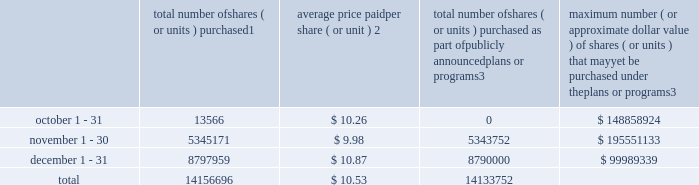Repurchase of equity securities the table provides information regarding our purchases of our equity securities during the period from october 1 , 2012 to december 31 , 2012 .
Total number of shares ( or units ) purchased 1 average price paid per share ( or unit ) 2 total number of shares ( or units ) purchased as part of publicly announced plans or programs 3 maximum number ( or approximate dollar value ) of shares ( or units ) that may yet be purchased under the plans or programs 3 .
1 includes shares of our common stock , par value $ 0.10 per share , withheld under the terms of grants under employee stock-based compensation plans to offset tax withholding obligations that occurred upon vesting and release of restricted shares ( the 201cwithheld shares 201d ) .
We repurchased 13566 withheld shares in october 2012 , 1419 withheld shares in november 2012 and 7959 withheld shares in december 2012 , for a total of 22944 withheld shares during the three-month period .
2 the average price per share for each of the months in the fiscal quarter and for the three-month period was calculated by dividing the sum of the applicable period of the aggregate value of the tax withholding obligations and the aggregate amount we paid for shares acquired under our stock repurchase program , described in note 5 to the consolidated financial statements , by the sum of the number of withheld shares and the number of shares acquired in our stock repurchase program .
3 on february 24 , 2012 , we announced in a press release that our board had approved a share repurchase program to repurchase from time to time up to $ 300.0 million of our common stock ( the 201c2012 share repurchase program 201d ) , in addition to amounts available on existing authorizations .
On november 20 , 2012 , we announced in a press release that our board had authorized an increase in our 2012 share repurchase program to $ 400.0 million of our common stock .
On february 22 , 2013 , we announced that our board had approved a new share repurchase program to repurchase from time to time up to $ 300.0 million of our common stock .
The new authorization is in addition to any amounts remaining available for repurchase under the 2012 share repurchase program .
There is no expiration date associated with the share repurchase programs. .
What was the percentage of the total number of shares ( or units ) purchased in december? 
Computations: (8797959 / 14156696)
Answer: 0.62147. 